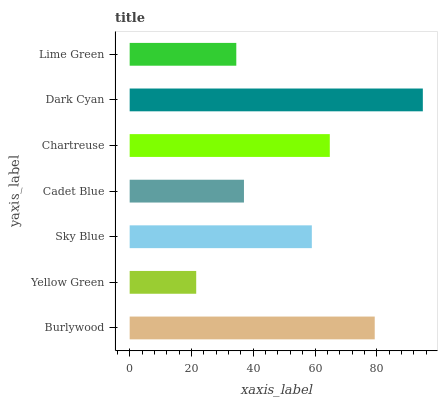Is Yellow Green the minimum?
Answer yes or no. Yes. Is Dark Cyan the maximum?
Answer yes or no. Yes. Is Sky Blue the minimum?
Answer yes or no. No. Is Sky Blue the maximum?
Answer yes or no. No. Is Sky Blue greater than Yellow Green?
Answer yes or no. Yes. Is Yellow Green less than Sky Blue?
Answer yes or no. Yes. Is Yellow Green greater than Sky Blue?
Answer yes or no. No. Is Sky Blue less than Yellow Green?
Answer yes or no. No. Is Sky Blue the high median?
Answer yes or no. Yes. Is Sky Blue the low median?
Answer yes or no. Yes. Is Cadet Blue the high median?
Answer yes or no. No. Is Chartreuse the low median?
Answer yes or no. No. 